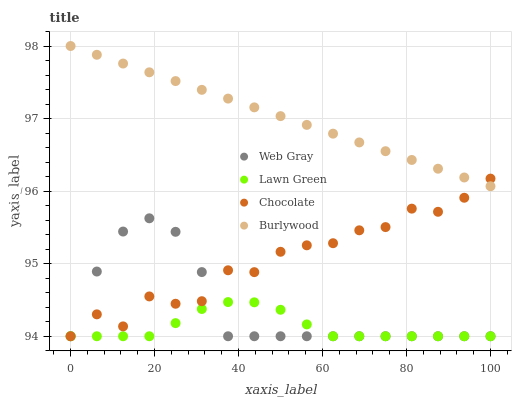Does Lawn Green have the minimum area under the curve?
Answer yes or no. Yes. Does Burlywood have the maximum area under the curve?
Answer yes or no. Yes. Does Web Gray have the minimum area under the curve?
Answer yes or no. No. Does Web Gray have the maximum area under the curve?
Answer yes or no. No. Is Burlywood the smoothest?
Answer yes or no. Yes. Is Chocolate the roughest?
Answer yes or no. Yes. Is Lawn Green the smoothest?
Answer yes or no. No. Is Lawn Green the roughest?
Answer yes or no. No. Does Lawn Green have the lowest value?
Answer yes or no. Yes. Does Burlywood have the highest value?
Answer yes or no. Yes. Does Web Gray have the highest value?
Answer yes or no. No. Is Lawn Green less than Burlywood?
Answer yes or no. Yes. Is Burlywood greater than Web Gray?
Answer yes or no. Yes. Does Lawn Green intersect Chocolate?
Answer yes or no. Yes. Is Lawn Green less than Chocolate?
Answer yes or no. No. Is Lawn Green greater than Chocolate?
Answer yes or no. No. Does Lawn Green intersect Burlywood?
Answer yes or no. No. 